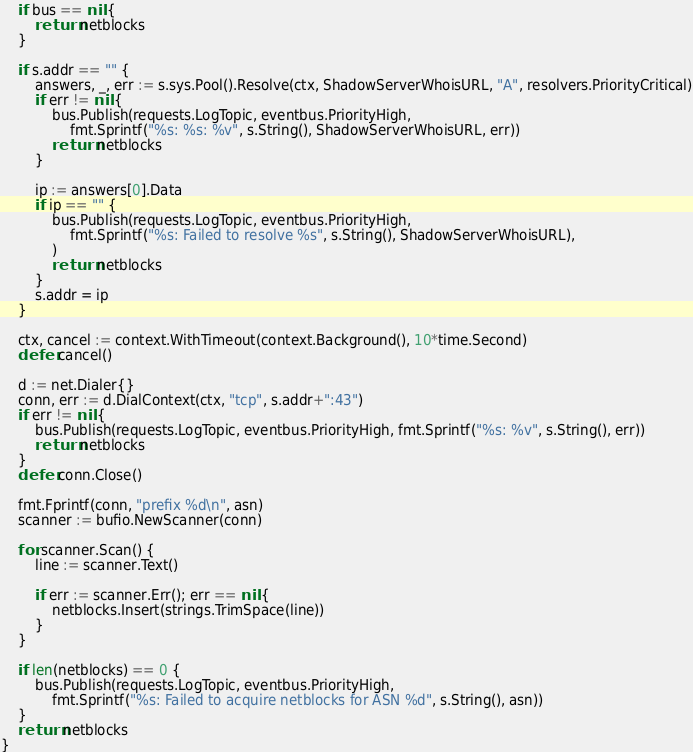<code> <loc_0><loc_0><loc_500><loc_500><_Go_>	if bus == nil {
		return netblocks
	}

	if s.addr == "" {
		answers, _, err := s.sys.Pool().Resolve(ctx, ShadowServerWhoisURL, "A", resolvers.PriorityCritical)
		if err != nil {
			bus.Publish(requests.LogTopic, eventbus.PriorityHigh,
				fmt.Sprintf("%s: %s: %v", s.String(), ShadowServerWhoisURL, err))
			return netblocks
		}

		ip := answers[0].Data
		if ip == "" {
			bus.Publish(requests.LogTopic, eventbus.PriorityHigh,
				fmt.Sprintf("%s: Failed to resolve %s", s.String(), ShadowServerWhoisURL),
			)
			return netblocks
		}
		s.addr = ip
	}

	ctx, cancel := context.WithTimeout(context.Background(), 10*time.Second)
	defer cancel()

	d := net.Dialer{}
	conn, err := d.DialContext(ctx, "tcp", s.addr+":43")
	if err != nil {
		bus.Publish(requests.LogTopic, eventbus.PriorityHigh, fmt.Sprintf("%s: %v", s.String(), err))
		return netblocks
	}
	defer conn.Close()

	fmt.Fprintf(conn, "prefix %d\n", asn)
	scanner := bufio.NewScanner(conn)

	for scanner.Scan() {
		line := scanner.Text()

		if err := scanner.Err(); err == nil {
			netblocks.Insert(strings.TrimSpace(line))
		}
	}

	if len(netblocks) == 0 {
		bus.Publish(requests.LogTopic, eventbus.PriorityHigh,
			fmt.Sprintf("%s: Failed to acquire netblocks for ASN %d", s.String(), asn))
	}
	return netblocks
}
</code> 